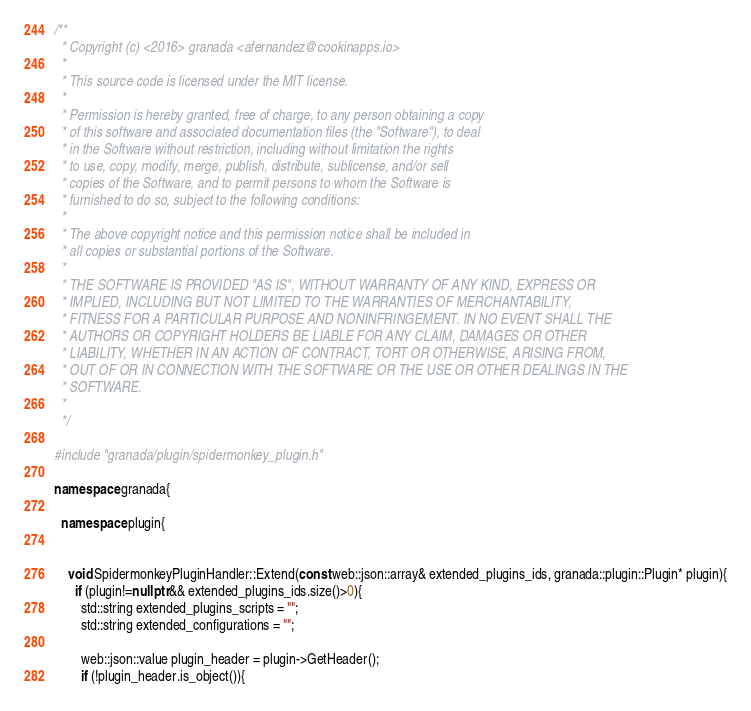Convert code to text. <code><loc_0><loc_0><loc_500><loc_500><_C++_>/**
  * Copyright (c) <2016> granada <afernandez@cookinapps.io>
  *
  * This source code is licensed under the MIT license.
  *
  * Permission is hereby granted, free of charge, to any person obtaining a copy
  * of this software and associated documentation files (the "Software"), to deal
  * in the Software without restriction, including without limitation the rights
  * to use, copy, modify, merge, publish, distribute, sublicense, and/or sell
  * copies of the Software, and to permit persons to whom the Software is
  * furnished to do so, subject to the following conditions:
  *
  * The above copyright notice and this permission notice shall be included in
  * all copies or substantial portions of the Software.
  *
  * THE SOFTWARE IS PROVIDED "AS IS", WITHOUT WARRANTY OF ANY KIND, EXPRESS OR
  * IMPLIED, INCLUDING BUT NOT LIMITED TO THE WARRANTIES OF MERCHANTABILITY,
  * FITNESS FOR A PARTICULAR PURPOSE AND NONINFRINGEMENT. IN NO EVENT SHALL THE
  * AUTHORS OR COPYRIGHT HOLDERS BE LIABLE FOR ANY CLAIM, DAMAGES OR OTHER
  * LIABILITY, WHETHER IN AN ACTION OF CONTRACT, TORT OR OTHERWISE, ARISING FROM,
  * OUT OF OR IN CONNECTION WITH THE SOFTWARE OR THE USE OR OTHER DEALINGS IN THE
  * SOFTWARE.
  *
  */

#include "granada/plugin/spidermonkey_plugin.h"

namespace granada{

  namespace plugin{


    void SpidermonkeyPluginHandler::Extend(const web::json::array& extended_plugins_ids, granada::plugin::Plugin* plugin){
      if (plugin!=nullptr && extended_plugins_ids.size()>0){
        std::string extended_plugins_scripts = "";
        std::string extended_configurations = "";

        web::json::value plugin_header = plugin->GetHeader();
        if (!plugin_header.is_object()){</code> 